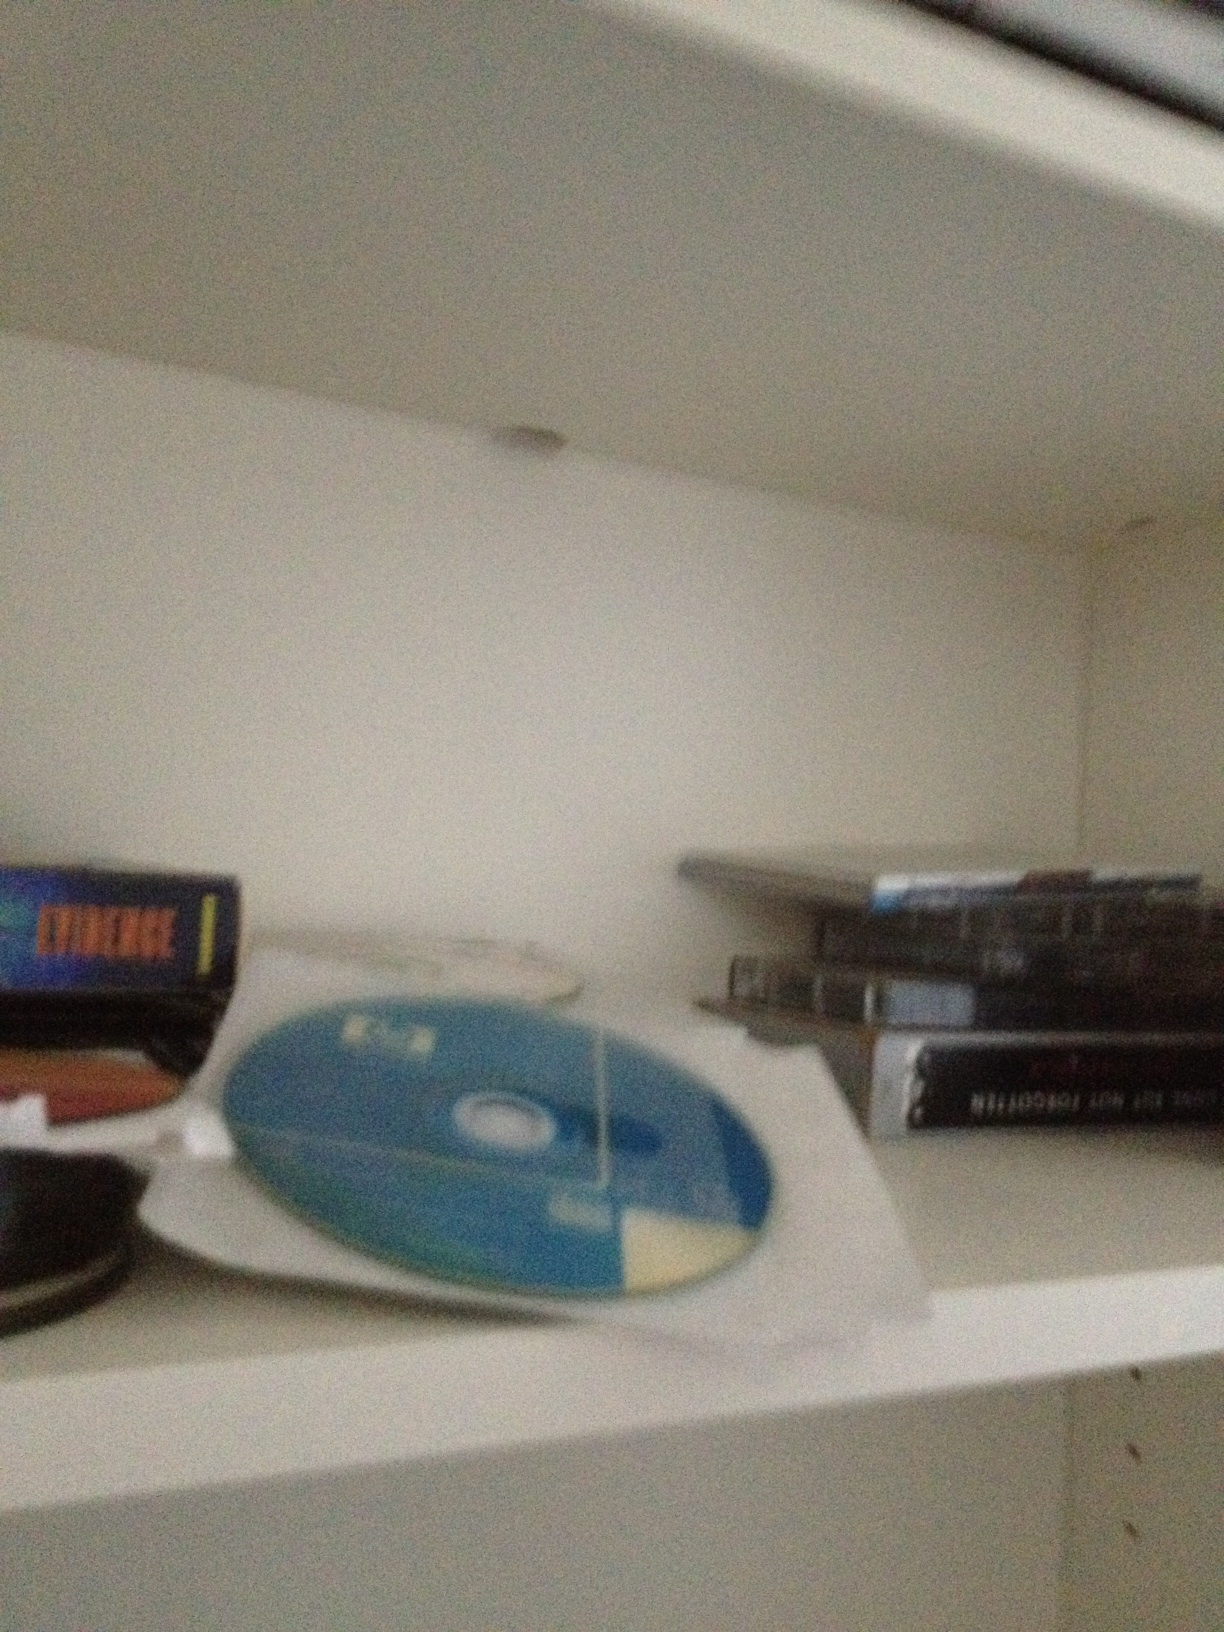What kind of media do you think these discs contain? These discs could contain a variety of media, including music albums, movies, computer software, or video games. The mix of both loose and cased discs suggests a collection of different types of media. Do you think there might be any rare or valuable items in this collection? It's possible that there might be some rare or valuable items in this collection. For instance, certain music albums or software editions can be collectible. If any of the CDs or DVDs are limited editions or out of print, they could hold considerable value for collectors. 